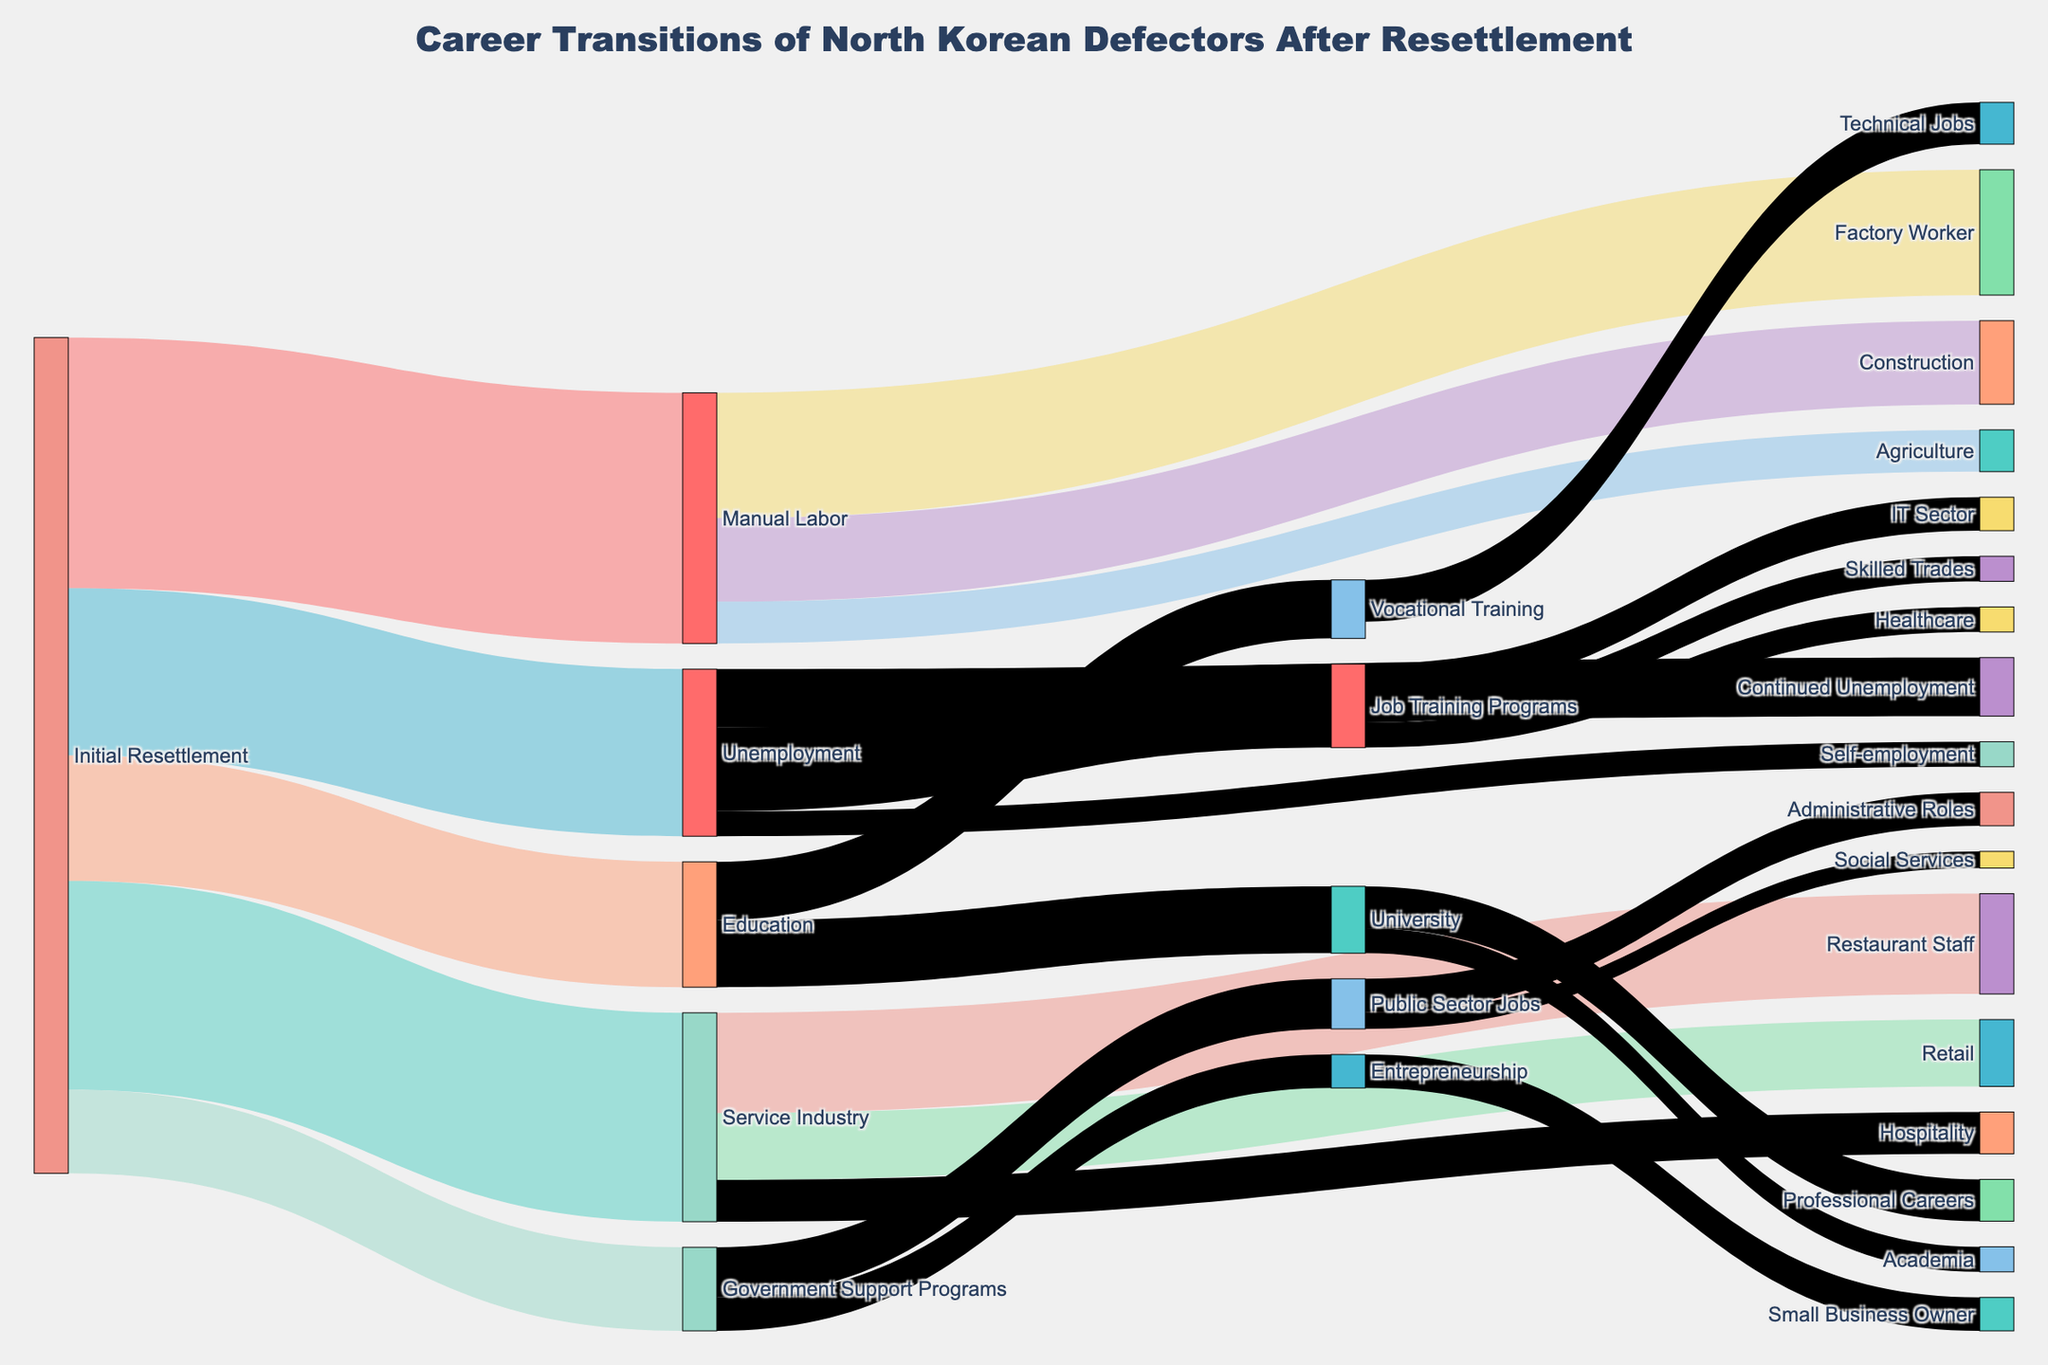what is the title of the Sankey diagram? The title of the Sankey diagram is located at the top center of the figure. It describes the subject of the visual representation. The title is "Career Transitions of North Korean Defectors After Resettlement".
Answer: Career Transitions of North Korean Defectors After Resettlement How many defectors transitioned directly from 'Initial Resettlement' to 'Manual Labor'? To find this, look for the flow lines (links) originating from 'Initial Resettlement' and leading to 'Manual Labor.' The value associated with this transition is displayed on the link.
Answer: 300 Which career path has the highest number of defectors transitioning to 'Factory Worker' from 'Manual Labor'? Check the originating node 'Manual Labor' and follow the links to 'Factory Worker.' The value on this link shows the number of defectors making this transition.
Answer: 150 From 'Initial Resettlement,' which career path does the fewest number of defectors take? Look for the node 'Initial Resettlement' and compare the values of the links leading from it. The link with the lowest value indicates the least taken path.
Answer: Government Support Programs How many defectors transitioned from 'Education' to 'University'? Identify the flow line from 'Education' to 'University' and note the value associated with this transition on the Sankey diagram.
Answer: 80 Which transition has a higher number of defectors, from 'Unemployment' to 'Job Training Programs' or from 'Unemployment' to 'Continued Unemployment'? Compare the values of the flow lines that transition from 'Unemployment' to 'Job Training Programs' and 'Unemployment' to 'Continued Unemployment.'
Answer: Job Training Programs What is the total number of defectors who transitioned to the 'Service Industry' directly after 'Initial Resettlement'? Sum the values of all the direct transitions from 'Initial Resettlement' to various nodes like 'Restaurant Staff,' 'Retail,' and 'Hospitality' under 'Service Industry.'
Answer: 250 How many defectors transitioned to 'Technical Jobs' from 'Vocational Training'? Find the node 'Vocational Training' and follow the link leading to 'Technical Jobs.' The value on this link represents the number of defectors for this transition.
Answer: 50 From 'Job Training Programs,' how many defectors transitioned to the 'IT Sector'? Locate 'Job Training Programs' and look for the link leading to 'IT Sector.' The value on this link indicates the number of defectors making this transition.
Answer: 40 Which two pathways have the highest number of defectors transitioning to 'Public Sector Jobs'? Identify the node 'Public Sector Jobs' and follow the links leading to it. Compare the values of these links to find the two highest. One link leads from 'Initial Resettlement,' and another from 'Government Support Programs.'
Answer: Government Support Programs, Initial Resettlement 